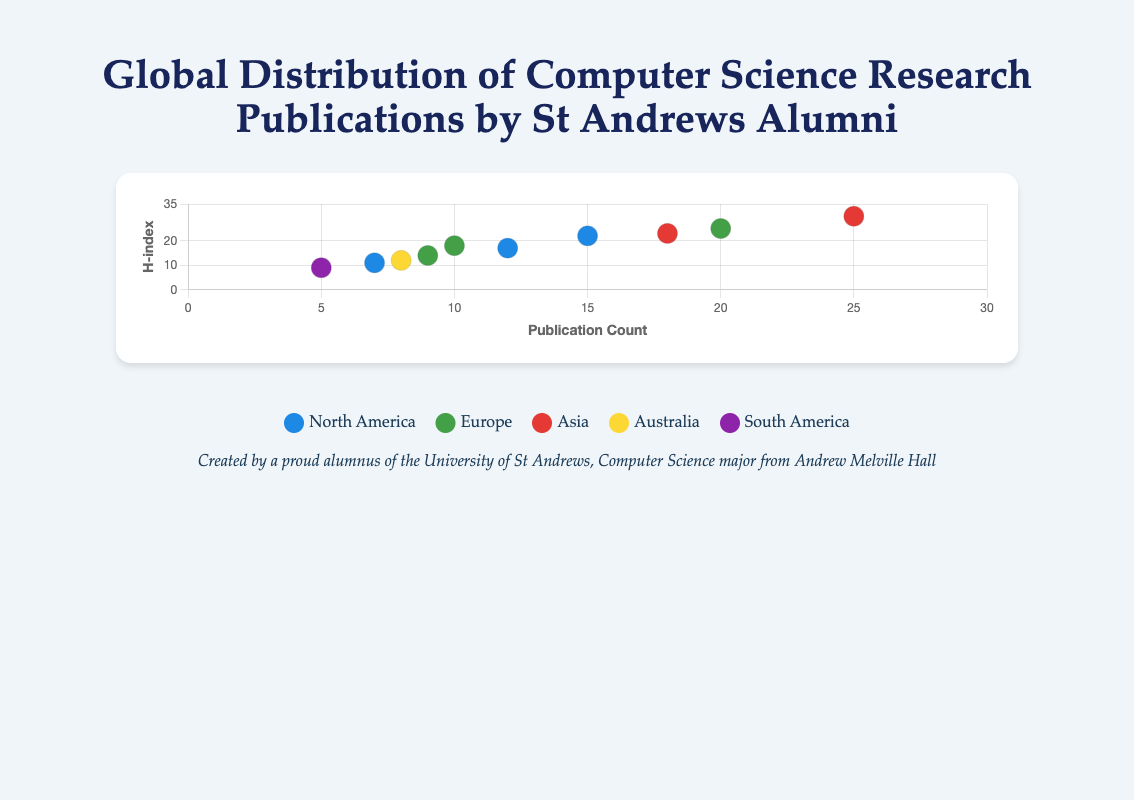How many alumni from St Andrews University are represented in the figure? The figure contains data points representing each alumnus. By counting these data points, we can determine the total number of alumni. There are data points for John Smith, Sarah Johnson, Robert Brown, Emily Davis, Michael Wilson, Jessica Garcia, Matthew Martinez, Laura Anderson, James Thomas, and Linda Lee.
Answer: 10 Which alumnus has the highest publication count, and what is that count? By looking at the x-axis, which represents publication count, we identify the data point furthest to the right. Robert Brown from Asia has the highest publication count of 25.
Answer: Robert Brown, 25 Which alumni are from Europe and what are their publication counts and h-index values? To answer this, we identify the alumni associated with the specific color that represents Europe. The alumni are Sarah Johnson, Jessica Garcia, and James Thomas. Their publication counts are: Sarah Johnson (10), Jessica Garcia (20), and James Thomas (9). Their h-index values are: Sarah Johnson (18), Jessica Garcia (25), and James Thomas (14).
Answer: Sarah Johnson: 10, 18; Jessica Garcia: 20, 25; James Thomas: 9, 14 How does the average h-index of alumni from North America compare to that of alumni from Europe? First, we calculate the average h-index for North America by summing the h-index values of John Smith (22), Matthew Martinez (17), and Linda Lee (11), then dividing by 3. Next, for Europe, we sum the values for Sarah Johnson (18), Jessica Garcia (25), and James Thomas (14), then divide by 3. For North America: (22 + 17 + 11) / 3 = 16.67. For Europe: (18 + 25 + 14) / 3 = 19.
Answer: North America: 16.67, Europe: 19 Which continent has the alumnus with the lowest h-index, and who is this alumnus? By observing the y-axis for the lowest h-index value, we find that Michael Wilson from South America has the lowest h-index of 9.
Answer: South America, Michael Wilson What is the difference in the number of publications between Robert Brown and Emily Davis? By comparing the x-axis values for Robert Brown (25) and Emily Davis (8), the difference in their publication counts is 25 - 8.
Answer: 17 Identify the alumni who have a publication count between 10 and 20. What are their h-index values and universities? By analyzing the x-axis for publication counts between 10 and 20, we find John Smith (Stanford University, h-index 22), Sarah Johnson (ETH Zurich, h-index 18), Matthew Martinez (MIT, h-index 17), and Laura Anderson (National University of Singapore, h-index 23).
Answer: John Smith: 22, Stanford University; Sarah Johnson: 18, ETH Zurich; Matthew Martinez: 17, MIT; Laura Anderson: 23, National University of Singapore Which continent is represented by the most number of alumni in the figure? By counting the number of alumni data points associated with each continent's respective color, Europe has three alumni, North America also has three, Asia has two, while Australia and South America each have one. Europe and North America tie with the most alumni.
Answer: Europe, North America 